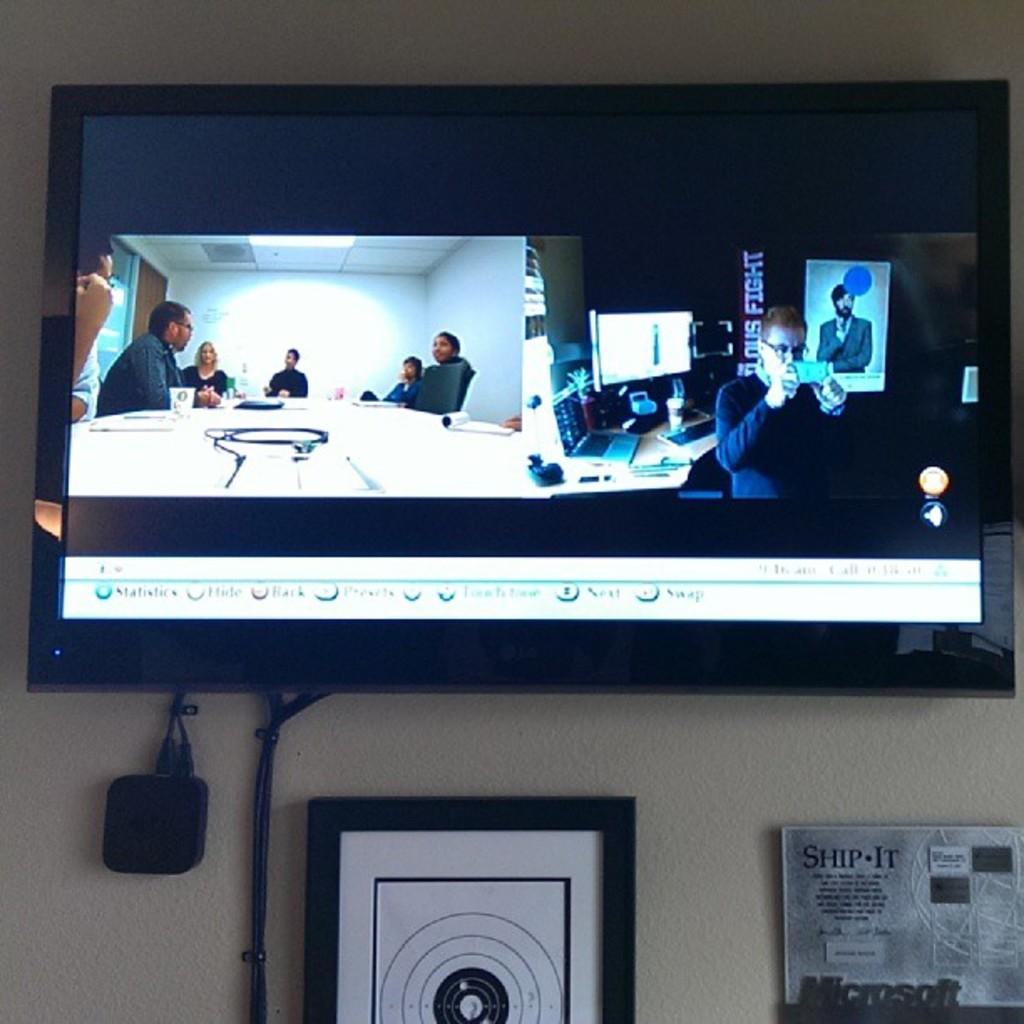<image>
Summarize the visual content of the image. A television is on the wall and there is a sign under it that says, "SHIP-IT". 